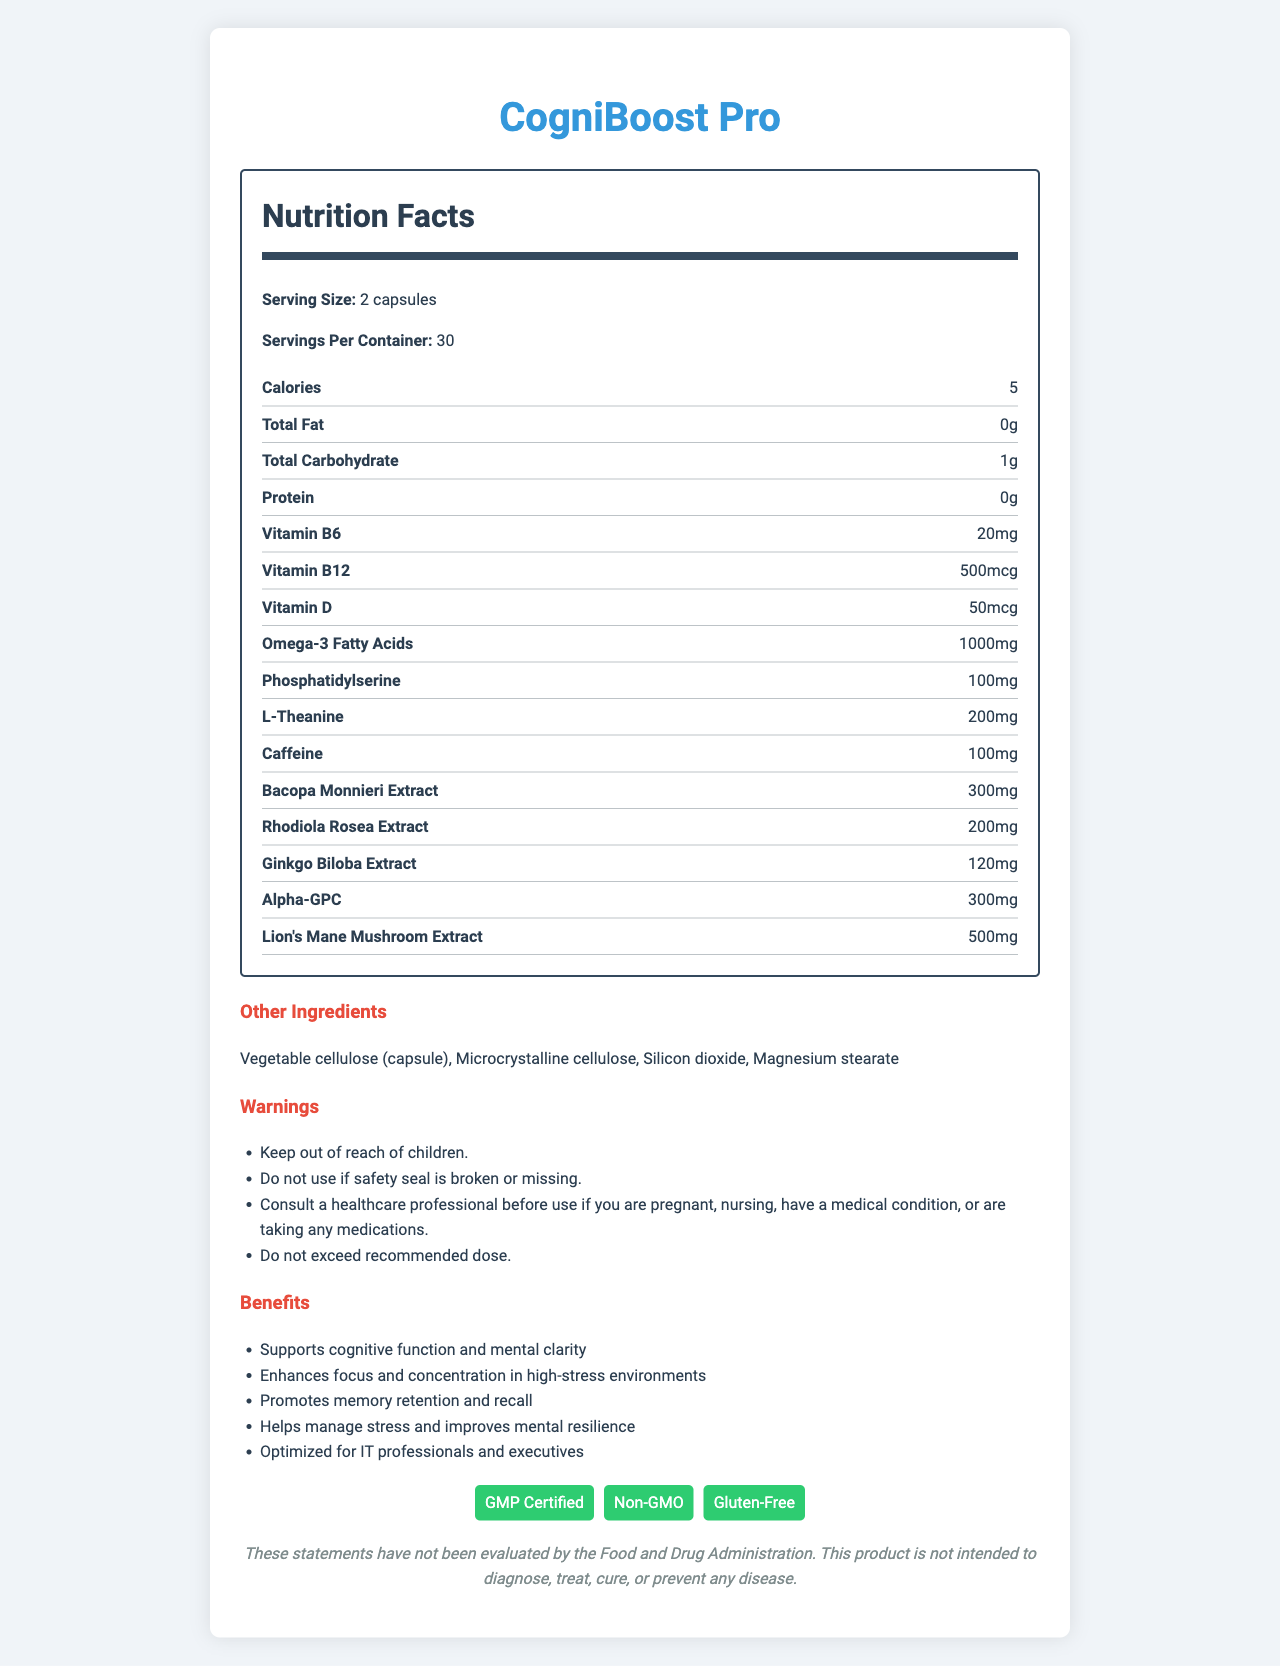what is the serving size for CogniBoost Pro? The serving size is clearly indicated as "2 capsules" in the nutrition facts section.
Answer: 2 capsules how many calories are in one serving of CogniBoost Pro? The nutrition facts label shows that one serving contains 5 calories.
Answer: 5 what potential allergens are present in CogniBoost Pro? The allergen information specifies that it contains fish sourced from omega-3 fatty acids.
Answer: Contains fish (sourced from omega-3 fatty acids). how many servings are there in each container of CogniBoost Pro? The label states "Servings Per Container: 30".
Answer: 30 what is the suggested use for CogniBoost Pro? The suggested use is mentioned in the document under suggested use instructions.
Answer: Take 2 capsules daily with food, preferably in the morning or as directed by a healthcare professional. which ingredient in CogniBoost Pro is present in the largest amount? Among the listed ingredients, Omega-3 Fatty Acids have the highest amount at 1000mg.
Answer: Omega-3 Fatty Acids (1000mg) what are the certifications listed for CogniBoost Pro? These certifications are specified at the bottom of the document.
Answer: GMP Certified, Non-GMO, Gluten-Free which of the following ingredients is NOT part of the other ingredients list? A. Microcrystalline cellulose B. Silicon dioxide C. Gelatin D. Magnesium stearate Gelatin is not listed in the other ingredients; the other options are all included.
Answer: C which benefit is mentioned as a focus of CogniBoost Pro for high-stress environments? A. Supports digestive health B. Enhances focus and concentration C. Improves sleep quality D. Increases energy levels The document states "Enhances focus and concentration in high-stress environments" as one of the benefits.
Answer: B is CogniBoost Pro suitable for vegetarians? The product contains fish (sourced from omega-3 fatty acids), making it unsuitable for vegetarians.
Answer: No summarize the purpose and key details of the CogniBoost Pro nutrition label. The summary includes the product's purpose, key benefits, serving details, significant ingredients, certifications, usage instructions, allergen information, and warnings.
Answer: CogniBoost Pro is a brain-boosting supplement designed to enhance cognitive performance in high-stress work environments. It offers cognitive benefits such as improved memory, focus, and stress management. The serving size is 2 capsules, with each container holding 30 servings. Key ingredients include Omega-3 Fatty Acids, Phosphatidylserine, L-Theanine, and several extracts like Bacopa Monnieri and Rhodiola Rosea. It is GMP Certified, Non-GMO, and Gluten-Free. Suggested usage and allergen information are provided, along with various warnings. what is the source of omega-3 fatty acids in CogniBoost Pro? The document specifies the presence of omega-3 fatty acids but does not provide detailed information about their exact source.
Answer: Cannot be determined which warnings are listed for the use of CogniBoost Pro? These warnings are all clearly listed under the warnings section in the document.
Answer: Several warnings, including: Keep out of reach of children, do not use if the safety seal is broken or missing, consult a healthcare professional before use if pregnant, nursing, have a medical condition, or are taking medications, and do not exceed the recommended dose. 